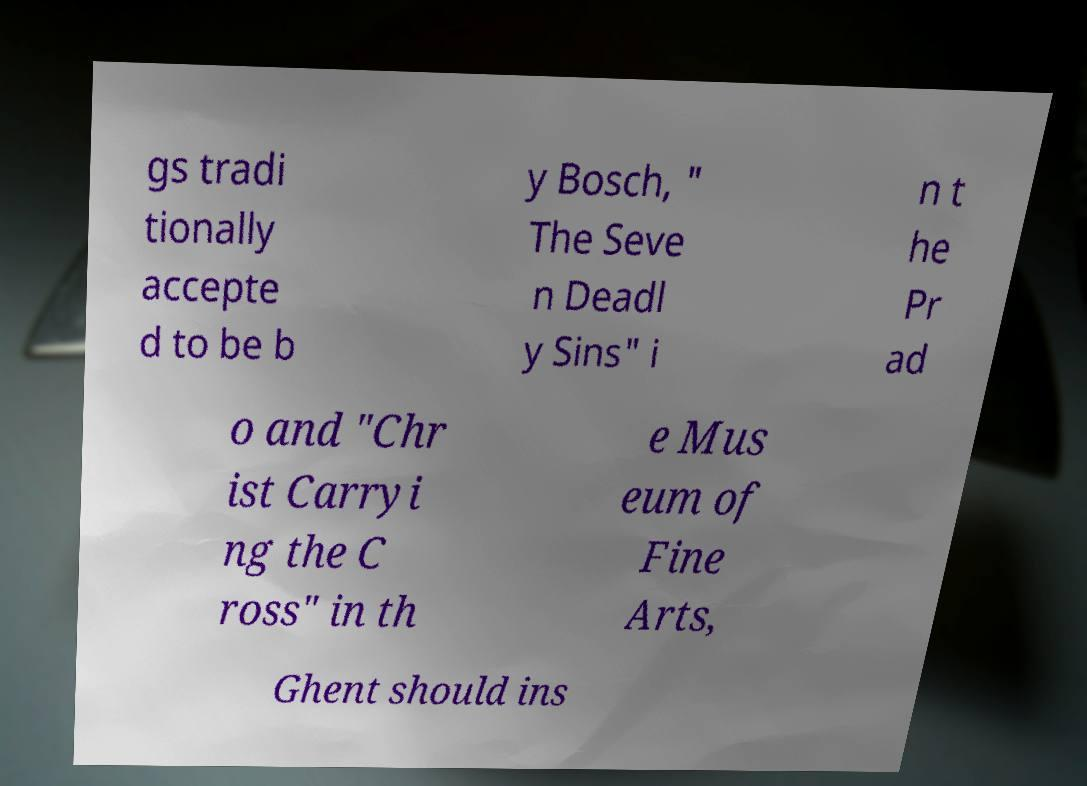There's text embedded in this image that I need extracted. Can you transcribe it verbatim? gs tradi tionally accepte d to be b y Bosch, " The Seve n Deadl y Sins" i n t he Pr ad o and "Chr ist Carryi ng the C ross" in th e Mus eum of Fine Arts, Ghent should ins 